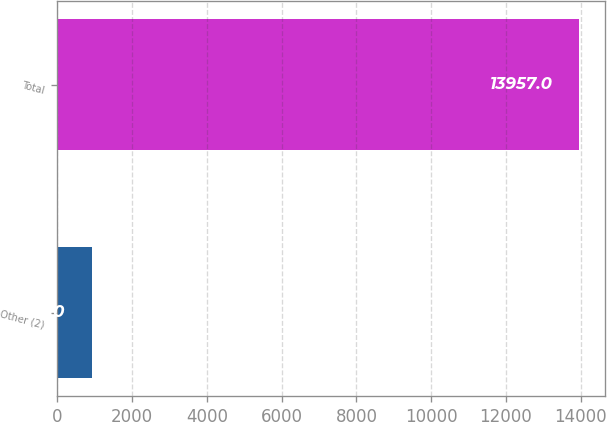Convert chart to OTSL. <chart><loc_0><loc_0><loc_500><loc_500><bar_chart><fcel>Other (2)<fcel>Total<nl><fcel>920<fcel>13957<nl></chart> 